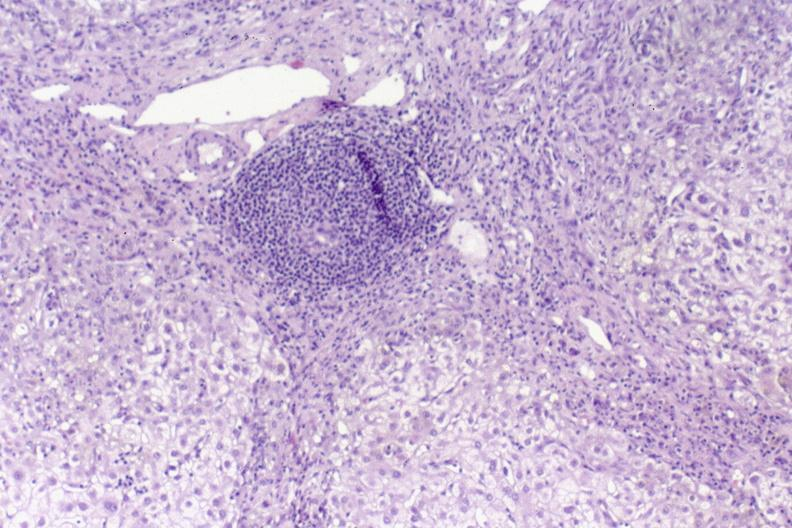what does this image show?
Answer the question using a single word or phrase. Primary biliary cirrhosis 